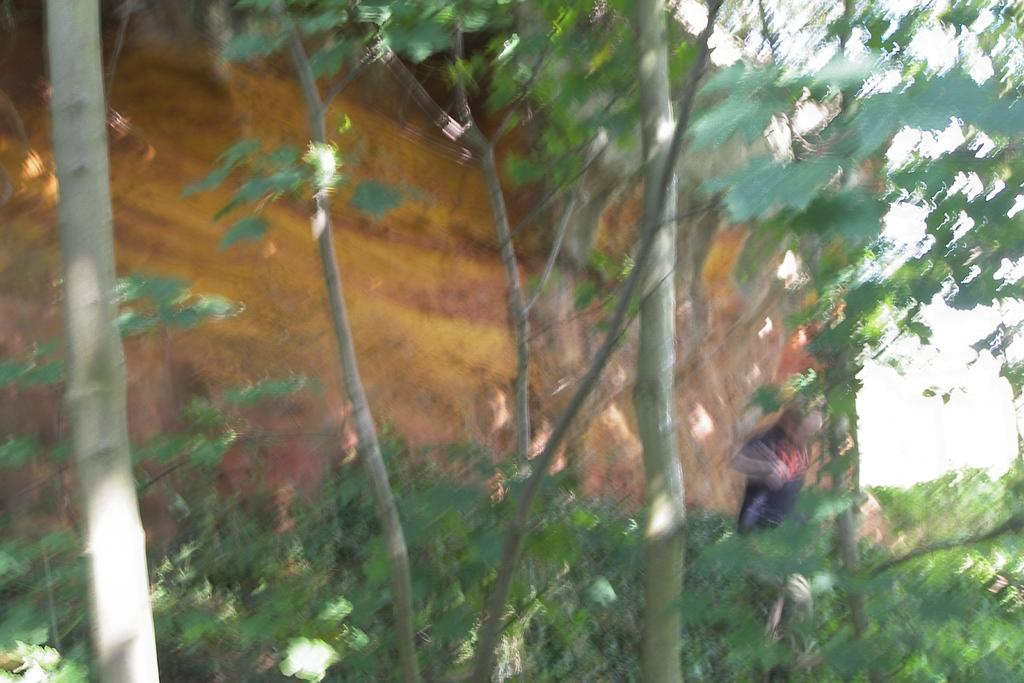What can be seen in the foreground of the image? There is a group of trees and plants in the foreground of the image. Is there any human presence in the foreground of the image? Yes, there is a person standing on the ground in the foreground of the image. What can be seen in the background of the image? There are mountains and the sky visible in the background of the image. What type of ice can be seen growing from the roots of the trees in the image? There is no ice present in the image, and trees do not have roots that grow ice. What is the aftermath of the event depicted in the image? There is no event depicted in the image, so it is not possible to determine the aftermath. 